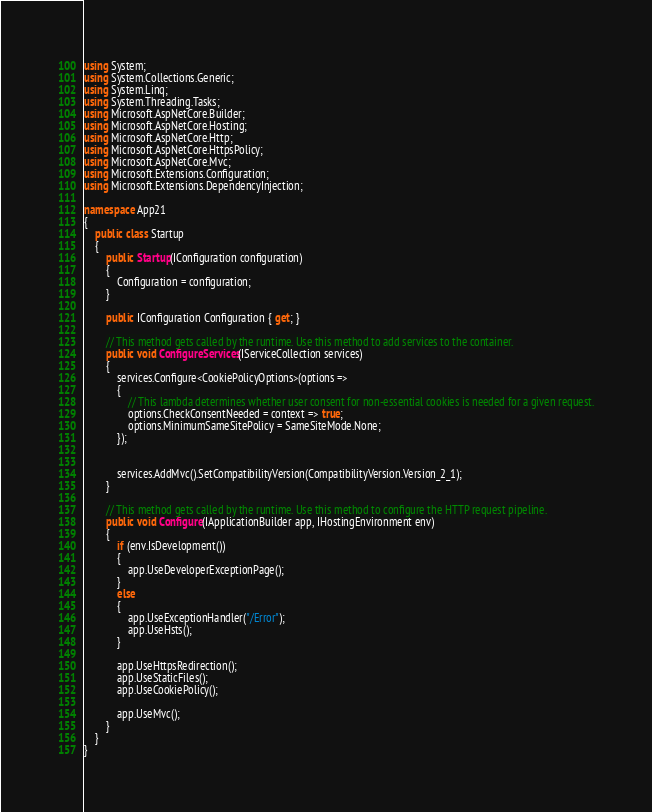<code> <loc_0><loc_0><loc_500><loc_500><_C#_>using System;
using System.Collections.Generic;
using System.Linq;
using System.Threading.Tasks;
using Microsoft.AspNetCore.Builder;
using Microsoft.AspNetCore.Hosting;
using Microsoft.AspNetCore.Http;
using Microsoft.AspNetCore.HttpsPolicy;
using Microsoft.AspNetCore.Mvc;
using Microsoft.Extensions.Configuration;
using Microsoft.Extensions.DependencyInjection;

namespace App21
{
    public class Startup
    {
        public Startup(IConfiguration configuration)
        {
            Configuration = configuration;
        }

        public IConfiguration Configuration { get; }

        // This method gets called by the runtime. Use this method to add services to the container.
        public void ConfigureServices(IServiceCollection services)
        {
            services.Configure<CookiePolicyOptions>(options =>
            {
                // This lambda determines whether user consent for non-essential cookies is needed for a given request.
                options.CheckConsentNeeded = context => true;
                options.MinimumSameSitePolicy = SameSiteMode.None;
            });


            services.AddMvc().SetCompatibilityVersion(CompatibilityVersion.Version_2_1);
        }

        // This method gets called by the runtime. Use this method to configure the HTTP request pipeline.
        public void Configure(IApplicationBuilder app, IHostingEnvironment env)
        {
            if (env.IsDevelopment())
            {
                app.UseDeveloperExceptionPage();
            }
            else
            {
                app.UseExceptionHandler("/Error");
                app.UseHsts();
            }

            app.UseHttpsRedirection();
            app.UseStaticFiles();
            app.UseCookiePolicy();

            app.UseMvc();
        }
    }
}
</code> 